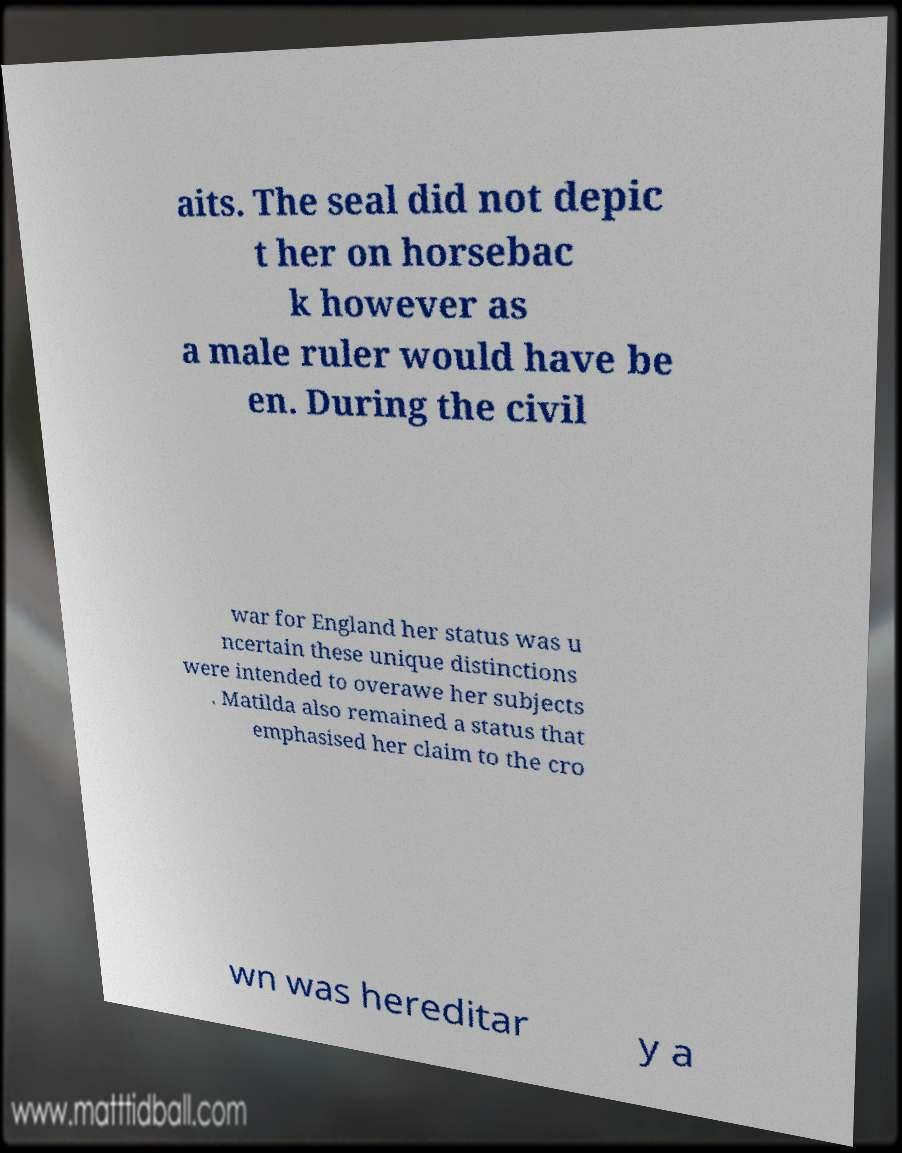Please identify and transcribe the text found in this image. aits. The seal did not depic t her on horsebac k however as a male ruler would have be en. During the civil war for England her status was u ncertain these unique distinctions were intended to overawe her subjects . Matilda also remained a status that emphasised her claim to the cro wn was hereditar y a 